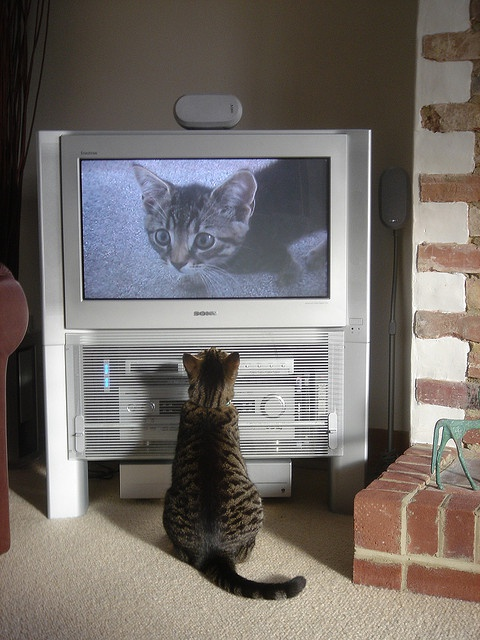Describe the objects in this image and their specific colors. I can see tv in black, gray, darkgray, and lightgray tones, cat in black and gray tones, and cat in black and gray tones in this image. 